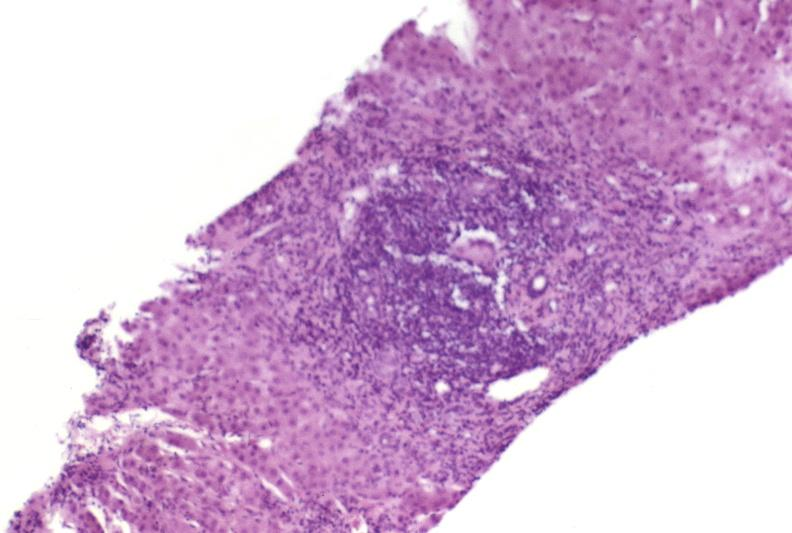what is present?
Answer the question using a single word or phrase. Hepatobiliary 